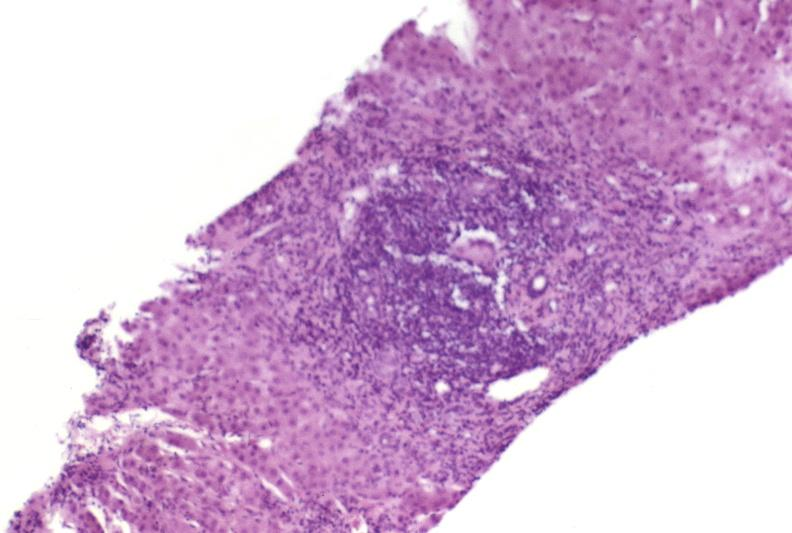what is present?
Answer the question using a single word or phrase. Hepatobiliary 